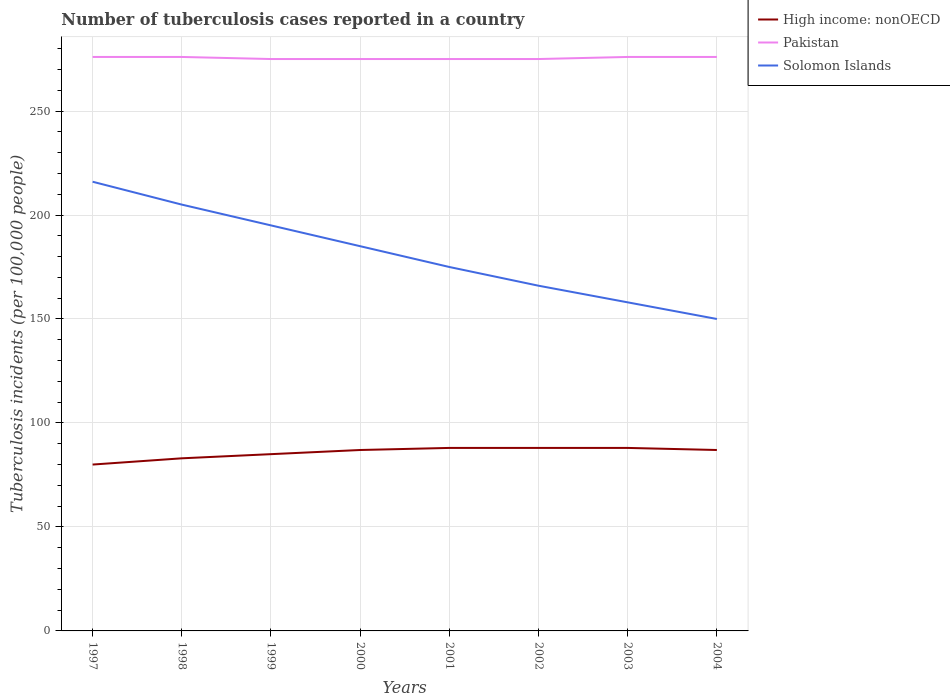Is the number of lines equal to the number of legend labels?
Your answer should be compact. Yes. Across all years, what is the maximum number of tuberculosis cases reported in in Solomon Islands?
Make the answer very short. 150. In which year was the number of tuberculosis cases reported in in Pakistan maximum?
Ensure brevity in your answer.  1999. What is the difference between the highest and the second highest number of tuberculosis cases reported in in High income: nonOECD?
Offer a very short reply. 8. How many lines are there?
Give a very brief answer. 3. Does the graph contain any zero values?
Provide a succinct answer. No. Where does the legend appear in the graph?
Offer a terse response. Top right. How many legend labels are there?
Provide a short and direct response. 3. What is the title of the graph?
Make the answer very short. Number of tuberculosis cases reported in a country. Does "High income: nonOECD" appear as one of the legend labels in the graph?
Your answer should be very brief. Yes. What is the label or title of the X-axis?
Your answer should be compact. Years. What is the label or title of the Y-axis?
Offer a very short reply. Tuberculosis incidents (per 100,0 people). What is the Tuberculosis incidents (per 100,000 people) of Pakistan in 1997?
Offer a very short reply. 276. What is the Tuberculosis incidents (per 100,000 people) of Solomon Islands in 1997?
Offer a very short reply. 216. What is the Tuberculosis incidents (per 100,000 people) in Pakistan in 1998?
Your answer should be very brief. 276. What is the Tuberculosis incidents (per 100,000 people) in Solomon Islands in 1998?
Provide a short and direct response. 205. What is the Tuberculosis incidents (per 100,000 people) in Pakistan in 1999?
Provide a succinct answer. 275. What is the Tuberculosis incidents (per 100,000 people) of Solomon Islands in 1999?
Ensure brevity in your answer.  195. What is the Tuberculosis incidents (per 100,000 people) of High income: nonOECD in 2000?
Give a very brief answer. 87. What is the Tuberculosis incidents (per 100,000 people) in Pakistan in 2000?
Make the answer very short. 275. What is the Tuberculosis incidents (per 100,000 people) in Solomon Islands in 2000?
Offer a terse response. 185. What is the Tuberculosis incidents (per 100,000 people) in Pakistan in 2001?
Give a very brief answer. 275. What is the Tuberculosis incidents (per 100,000 people) of Solomon Islands in 2001?
Your answer should be very brief. 175. What is the Tuberculosis incidents (per 100,000 people) of Pakistan in 2002?
Give a very brief answer. 275. What is the Tuberculosis incidents (per 100,000 people) in Solomon Islands in 2002?
Make the answer very short. 166. What is the Tuberculosis incidents (per 100,000 people) of High income: nonOECD in 2003?
Offer a very short reply. 88. What is the Tuberculosis incidents (per 100,000 people) in Pakistan in 2003?
Provide a short and direct response. 276. What is the Tuberculosis incidents (per 100,000 people) in Solomon Islands in 2003?
Your answer should be very brief. 158. What is the Tuberculosis incidents (per 100,000 people) of High income: nonOECD in 2004?
Offer a terse response. 87. What is the Tuberculosis incidents (per 100,000 people) in Pakistan in 2004?
Offer a terse response. 276. What is the Tuberculosis incidents (per 100,000 people) in Solomon Islands in 2004?
Keep it short and to the point. 150. Across all years, what is the maximum Tuberculosis incidents (per 100,000 people) of Pakistan?
Your answer should be compact. 276. Across all years, what is the maximum Tuberculosis incidents (per 100,000 people) of Solomon Islands?
Your answer should be compact. 216. Across all years, what is the minimum Tuberculosis incidents (per 100,000 people) in Pakistan?
Your answer should be compact. 275. Across all years, what is the minimum Tuberculosis incidents (per 100,000 people) in Solomon Islands?
Give a very brief answer. 150. What is the total Tuberculosis incidents (per 100,000 people) in High income: nonOECD in the graph?
Provide a succinct answer. 686. What is the total Tuberculosis incidents (per 100,000 people) in Pakistan in the graph?
Provide a succinct answer. 2204. What is the total Tuberculosis incidents (per 100,000 people) of Solomon Islands in the graph?
Keep it short and to the point. 1450. What is the difference between the Tuberculosis incidents (per 100,000 people) in High income: nonOECD in 1997 and that in 1998?
Ensure brevity in your answer.  -3. What is the difference between the Tuberculosis incidents (per 100,000 people) of Pakistan in 1997 and that in 1998?
Provide a succinct answer. 0. What is the difference between the Tuberculosis incidents (per 100,000 people) of Solomon Islands in 1997 and that in 1998?
Your response must be concise. 11. What is the difference between the Tuberculosis incidents (per 100,000 people) in Pakistan in 1997 and that in 1999?
Make the answer very short. 1. What is the difference between the Tuberculosis incidents (per 100,000 people) in High income: nonOECD in 1997 and that in 2000?
Provide a short and direct response. -7. What is the difference between the Tuberculosis incidents (per 100,000 people) of Pakistan in 1997 and that in 2000?
Provide a short and direct response. 1. What is the difference between the Tuberculosis incidents (per 100,000 people) in Pakistan in 1997 and that in 2002?
Offer a terse response. 1. What is the difference between the Tuberculosis incidents (per 100,000 people) in Solomon Islands in 1997 and that in 2004?
Ensure brevity in your answer.  66. What is the difference between the Tuberculosis incidents (per 100,000 people) of Pakistan in 1998 and that in 1999?
Your answer should be very brief. 1. What is the difference between the Tuberculosis incidents (per 100,000 people) of Solomon Islands in 1998 and that in 1999?
Your answer should be very brief. 10. What is the difference between the Tuberculosis incidents (per 100,000 people) in Pakistan in 1998 and that in 2000?
Provide a succinct answer. 1. What is the difference between the Tuberculosis incidents (per 100,000 people) in High income: nonOECD in 1998 and that in 2001?
Make the answer very short. -5. What is the difference between the Tuberculosis incidents (per 100,000 people) of Pakistan in 1998 and that in 2001?
Offer a very short reply. 1. What is the difference between the Tuberculosis incidents (per 100,000 people) in Solomon Islands in 1998 and that in 2001?
Your answer should be very brief. 30. What is the difference between the Tuberculosis incidents (per 100,000 people) of High income: nonOECD in 1998 and that in 2002?
Your response must be concise. -5. What is the difference between the Tuberculosis incidents (per 100,000 people) in Solomon Islands in 1998 and that in 2002?
Ensure brevity in your answer.  39. What is the difference between the Tuberculosis incidents (per 100,000 people) of High income: nonOECD in 1998 and that in 2003?
Your response must be concise. -5. What is the difference between the Tuberculosis incidents (per 100,000 people) of Pakistan in 1998 and that in 2004?
Give a very brief answer. 0. What is the difference between the Tuberculosis incidents (per 100,000 people) of Solomon Islands in 1999 and that in 2000?
Provide a short and direct response. 10. What is the difference between the Tuberculosis incidents (per 100,000 people) in High income: nonOECD in 1999 and that in 2001?
Provide a succinct answer. -3. What is the difference between the Tuberculosis incidents (per 100,000 people) of Solomon Islands in 1999 and that in 2002?
Offer a very short reply. 29. What is the difference between the Tuberculosis incidents (per 100,000 people) in High income: nonOECD in 1999 and that in 2003?
Your response must be concise. -3. What is the difference between the Tuberculosis incidents (per 100,000 people) in Pakistan in 1999 and that in 2003?
Your answer should be very brief. -1. What is the difference between the Tuberculosis incidents (per 100,000 people) in Solomon Islands in 1999 and that in 2003?
Give a very brief answer. 37. What is the difference between the Tuberculosis incidents (per 100,000 people) of High income: nonOECD in 1999 and that in 2004?
Give a very brief answer. -2. What is the difference between the Tuberculosis incidents (per 100,000 people) of High income: nonOECD in 2000 and that in 2002?
Keep it short and to the point. -1. What is the difference between the Tuberculosis incidents (per 100,000 people) of Pakistan in 2000 and that in 2002?
Give a very brief answer. 0. What is the difference between the Tuberculosis incidents (per 100,000 people) of Solomon Islands in 2000 and that in 2002?
Keep it short and to the point. 19. What is the difference between the Tuberculosis incidents (per 100,000 people) in High income: nonOECD in 2000 and that in 2003?
Offer a very short reply. -1. What is the difference between the Tuberculosis incidents (per 100,000 people) of Pakistan in 2000 and that in 2003?
Provide a succinct answer. -1. What is the difference between the Tuberculosis incidents (per 100,000 people) in High income: nonOECD in 2000 and that in 2004?
Your answer should be compact. 0. What is the difference between the Tuberculosis incidents (per 100,000 people) in Solomon Islands in 2000 and that in 2004?
Your answer should be compact. 35. What is the difference between the Tuberculosis incidents (per 100,000 people) in Solomon Islands in 2001 and that in 2002?
Your answer should be compact. 9. What is the difference between the Tuberculosis incidents (per 100,000 people) of High income: nonOECD in 2001 and that in 2003?
Your response must be concise. 0. What is the difference between the Tuberculosis incidents (per 100,000 people) in Pakistan in 2001 and that in 2003?
Ensure brevity in your answer.  -1. What is the difference between the Tuberculosis incidents (per 100,000 people) in Pakistan in 2001 and that in 2004?
Your answer should be very brief. -1. What is the difference between the Tuberculosis incidents (per 100,000 people) in Solomon Islands in 2001 and that in 2004?
Provide a succinct answer. 25. What is the difference between the Tuberculosis incidents (per 100,000 people) in Solomon Islands in 2002 and that in 2003?
Your answer should be compact. 8. What is the difference between the Tuberculosis incidents (per 100,000 people) in High income: nonOECD in 2002 and that in 2004?
Make the answer very short. 1. What is the difference between the Tuberculosis incidents (per 100,000 people) in Pakistan in 2002 and that in 2004?
Your response must be concise. -1. What is the difference between the Tuberculosis incidents (per 100,000 people) of Solomon Islands in 2002 and that in 2004?
Offer a terse response. 16. What is the difference between the Tuberculosis incidents (per 100,000 people) of Pakistan in 2003 and that in 2004?
Give a very brief answer. 0. What is the difference between the Tuberculosis incidents (per 100,000 people) of High income: nonOECD in 1997 and the Tuberculosis incidents (per 100,000 people) of Pakistan in 1998?
Make the answer very short. -196. What is the difference between the Tuberculosis incidents (per 100,000 people) in High income: nonOECD in 1997 and the Tuberculosis incidents (per 100,000 people) in Solomon Islands in 1998?
Your answer should be very brief. -125. What is the difference between the Tuberculosis incidents (per 100,000 people) of Pakistan in 1997 and the Tuberculosis incidents (per 100,000 people) of Solomon Islands in 1998?
Provide a short and direct response. 71. What is the difference between the Tuberculosis incidents (per 100,000 people) of High income: nonOECD in 1997 and the Tuberculosis incidents (per 100,000 people) of Pakistan in 1999?
Your answer should be compact. -195. What is the difference between the Tuberculosis incidents (per 100,000 people) in High income: nonOECD in 1997 and the Tuberculosis incidents (per 100,000 people) in Solomon Islands in 1999?
Your response must be concise. -115. What is the difference between the Tuberculosis incidents (per 100,000 people) in High income: nonOECD in 1997 and the Tuberculosis incidents (per 100,000 people) in Pakistan in 2000?
Your answer should be compact. -195. What is the difference between the Tuberculosis incidents (per 100,000 people) in High income: nonOECD in 1997 and the Tuberculosis incidents (per 100,000 people) in Solomon Islands in 2000?
Offer a very short reply. -105. What is the difference between the Tuberculosis incidents (per 100,000 people) of Pakistan in 1997 and the Tuberculosis incidents (per 100,000 people) of Solomon Islands in 2000?
Offer a terse response. 91. What is the difference between the Tuberculosis incidents (per 100,000 people) of High income: nonOECD in 1997 and the Tuberculosis incidents (per 100,000 people) of Pakistan in 2001?
Provide a short and direct response. -195. What is the difference between the Tuberculosis incidents (per 100,000 people) of High income: nonOECD in 1997 and the Tuberculosis incidents (per 100,000 people) of Solomon Islands in 2001?
Make the answer very short. -95. What is the difference between the Tuberculosis incidents (per 100,000 people) in Pakistan in 1997 and the Tuberculosis incidents (per 100,000 people) in Solomon Islands in 2001?
Keep it short and to the point. 101. What is the difference between the Tuberculosis incidents (per 100,000 people) in High income: nonOECD in 1997 and the Tuberculosis incidents (per 100,000 people) in Pakistan in 2002?
Offer a terse response. -195. What is the difference between the Tuberculosis incidents (per 100,000 people) in High income: nonOECD in 1997 and the Tuberculosis incidents (per 100,000 people) in Solomon Islands in 2002?
Your answer should be very brief. -86. What is the difference between the Tuberculosis incidents (per 100,000 people) of Pakistan in 1997 and the Tuberculosis incidents (per 100,000 people) of Solomon Islands in 2002?
Give a very brief answer. 110. What is the difference between the Tuberculosis incidents (per 100,000 people) of High income: nonOECD in 1997 and the Tuberculosis incidents (per 100,000 people) of Pakistan in 2003?
Your answer should be compact. -196. What is the difference between the Tuberculosis incidents (per 100,000 people) of High income: nonOECD in 1997 and the Tuberculosis incidents (per 100,000 people) of Solomon Islands in 2003?
Provide a succinct answer. -78. What is the difference between the Tuberculosis incidents (per 100,000 people) in Pakistan in 1997 and the Tuberculosis incidents (per 100,000 people) in Solomon Islands in 2003?
Provide a short and direct response. 118. What is the difference between the Tuberculosis incidents (per 100,000 people) of High income: nonOECD in 1997 and the Tuberculosis incidents (per 100,000 people) of Pakistan in 2004?
Give a very brief answer. -196. What is the difference between the Tuberculosis incidents (per 100,000 people) of High income: nonOECD in 1997 and the Tuberculosis incidents (per 100,000 people) of Solomon Islands in 2004?
Your answer should be very brief. -70. What is the difference between the Tuberculosis incidents (per 100,000 people) of Pakistan in 1997 and the Tuberculosis incidents (per 100,000 people) of Solomon Islands in 2004?
Offer a very short reply. 126. What is the difference between the Tuberculosis incidents (per 100,000 people) of High income: nonOECD in 1998 and the Tuberculosis incidents (per 100,000 people) of Pakistan in 1999?
Keep it short and to the point. -192. What is the difference between the Tuberculosis incidents (per 100,000 people) of High income: nonOECD in 1998 and the Tuberculosis incidents (per 100,000 people) of Solomon Islands in 1999?
Offer a terse response. -112. What is the difference between the Tuberculosis incidents (per 100,000 people) in Pakistan in 1998 and the Tuberculosis incidents (per 100,000 people) in Solomon Islands in 1999?
Offer a very short reply. 81. What is the difference between the Tuberculosis incidents (per 100,000 people) in High income: nonOECD in 1998 and the Tuberculosis incidents (per 100,000 people) in Pakistan in 2000?
Your answer should be compact. -192. What is the difference between the Tuberculosis incidents (per 100,000 people) of High income: nonOECD in 1998 and the Tuberculosis incidents (per 100,000 people) of Solomon Islands in 2000?
Your response must be concise. -102. What is the difference between the Tuberculosis incidents (per 100,000 people) in Pakistan in 1998 and the Tuberculosis incidents (per 100,000 people) in Solomon Islands in 2000?
Your response must be concise. 91. What is the difference between the Tuberculosis incidents (per 100,000 people) of High income: nonOECD in 1998 and the Tuberculosis incidents (per 100,000 people) of Pakistan in 2001?
Your answer should be compact. -192. What is the difference between the Tuberculosis incidents (per 100,000 people) of High income: nonOECD in 1998 and the Tuberculosis incidents (per 100,000 people) of Solomon Islands in 2001?
Give a very brief answer. -92. What is the difference between the Tuberculosis incidents (per 100,000 people) of Pakistan in 1998 and the Tuberculosis incidents (per 100,000 people) of Solomon Islands in 2001?
Make the answer very short. 101. What is the difference between the Tuberculosis incidents (per 100,000 people) of High income: nonOECD in 1998 and the Tuberculosis incidents (per 100,000 people) of Pakistan in 2002?
Your answer should be compact. -192. What is the difference between the Tuberculosis incidents (per 100,000 people) in High income: nonOECD in 1998 and the Tuberculosis incidents (per 100,000 people) in Solomon Islands in 2002?
Provide a succinct answer. -83. What is the difference between the Tuberculosis incidents (per 100,000 people) of Pakistan in 1998 and the Tuberculosis incidents (per 100,000 people) of Solomon Islands in 2002?
Your answer should be very brief. 110. What is the difference between the Tuberculosis incidents (per 100,000 people) in High income: nonOECD in 1998 and the Tuberculosis incidents (per 100,000 people) in Pakistan in 2003?
Provide a short and direct response. -193. What is the difference between the Tuberculosis incidents (per 100,000 people) of High income: nonOECD in 1998 and the Tuberculosis incidents (per 100,000 people) of Solomon Islands in 2003?
Keep it short and to the point. -75. What is the difference between the Tuberculosis incidents (per 100,000 people) of Pakistan in 1998 and the Tuberculosis incidents (per 100,000 people) of Solomon Islands in 2003?
Ensure brevity in your answer.  118. What is the difference between the Tuberculosis incidents (per 100,000 people) in High income: nonOECD in 1998 and the Tuberculosis incidents (per 100,000 people) in Pakistan in 2004?
Ensure brevity in your answer.  -193. What is the difference between the Tuberculosis incidents (per 100,000 people) in High income: nonOECD in 1998 and the Tuberculosis incidents (per 100,000 people) in Solomon Islands in 2004?
Keep it short and to the point. -67. What is the difference between the Tuberculosis incidents (per 100,000 people) of Pakistan in 1998 and the Tuberculosis incidents (per 100,000 people) of Solomon Islands in 2004?
Ensure brevity in your answer.  126. What is the difference between the Tuberculosis incidents (per 100,000 people) of High income: nonOECD in 1999 and the Tuberculosis incidents (per 100,000 people) of Pakistan in 2000?
Offer a very short reply. -190. What is the difference between the Tuberculosis incidents (per 100,000 people) in High income: nonOECD in 1999 and the Tuberculosis incidents (per 100,000 people) in Solomon Islands in 2000?
Your answer should be very brief. -100. What is the difference between the Tuberculosis incidents (per 100,000 people) of High income: nonOECD in 1999 and the Tuberculosis incidents (per 100,000 people) of Pakistan in 2001?
Give a very brief answer. -190. What is the difference between the Tuberculosis incidents (per 100,000 people) of High income: nonOECD in 1999 and the Tuberculosis incidents (per 100,000 people) of Solomon Islands in 2001?
Make the answer very short. -90. What is the difference between the Tuberculosis incidents (per 100,000 people) in Pakistan in 1999 and the Tuberculosis incidents (per 100,000 people) in Solomon Islands in 2001?
Make the answer very short. 100. What is the difference between the Tuberculosis incidents (per 100,000 people) in High income: nonOECD in 1999 and the Tuberculosis incidents (per 100,000 people) in Pakistan in 2002?
Your answer should be compact. -190. What is the difference between the Tuberculosis incidents (per 100,000 people) in High income: nonOECD in 1999 and the Tuberculosis incidents (per 100,000 people) in Solomon Islands in 2002?
Offer a very short reply. -81. What is the difference between the Tuberculosis incidents (per 100,000 people) in Pakistan in 1999 and the Tuberculosis incidents (per 100,000 people) in Solomon Islands in 2002?
Offer a terse response. 109. What is the difference between the Tuberculosis incidents (per 100,000 people) of High income: nonOECD in 1999 and the Tuberculosis incidents (per 100,000 people) of Pakistan in 2003?
Make the answer very short. -191. What is the difference between the Tuberculosis incidents (per 100,000 people) of High income: nonOECD in 1999 and the Tuberculosis incidents (per 100,000 people) of Solomon Islands in 2003?
Provide a succinct answer. -73. What is the difference between the Tuberculosis incidents (per 100,000 people) in Pakistan in 1999 and the Tuberculosis incidents (per 100,000 people) in Solomon Islands in 2003?
Offer a very short reply. 117. What is the difference between the Tuberculosis incidents (per 100,000 people) of High income: nonOECD in 1999 and the Tuberculosis incidents (per 100,000 people) of Pakistan in 2004?
Provide a succinct answer. -191. What is the difference between the Tuberculosis incidents (per 100,000 people) of High income: nonOECD in 1999 and the Tuberculosis incidents (per 100,000 people) of Solomon Islands in 2004?
Keep it short and to the point. -65. What is the difference between the Tuberculosis incidents (per 100,000 people) of Pakistan in 1999 and the Tuberculosis incidents (per 100,000 people) of Solomon Islands in 2004?
Ensure brevity in your answer.  125. What is the difference between the Tuberculosis incidents (per 100,000 people) in High income: nonOECD in 2000 and the Tuberculosis incidents (per 100,000 people) in Pakistan in 2001?
Offer a very short reply. -188. What is the difference between the Tuberculosis incidents (per 100,000 people) of High income: nonOECD in 2000 and the Tuberculosis incidents (per 100,000 people) of Solomon Islands in 2001?
Keep it short and to the point. -88. What is the difference between the Tuberculosis incidents (per 100,000 people) of Pakistan in 2000 and the Tuberculosis incidents (per 100,000 people) of Solomon Islands in 2001?
Offer a terse response. 100. What is the difference between the Tuberculosis incidents (per 100,000 people) of High income: nonOECD in 2000 and the Tuberculosis incidents (per 100,000 people) of Pakistan in 2002?
Your answer should be compact. -188. What is the difference between the Tuberculosis incidents (per 100,000 people) in High income: nonOECD in 2000 and the Tuberculosis incidents (per 100,000 people) in Solomon Islands in 2002?
Your response must be concise. -79. What is the difference between the Tuberculosis incidents (per 100,000 people) of Pakistan in 2000 and the Tuberculosis incidents (per 100,000 people) of Solomon Islands in 2002?
Provide a short and direct response. 109. What is the difference between the Tuberculosis incidents (per 100,000 people) of High income: nonOECD in 2000 and the Tuberculosis incidents (per 100,000 people) of Pakistan in 2003?
Keep it short and to the point. -189. What is the difference between the Tuberculosis incidents (per 100,000 people) in High income: nonOECD in 2000 and the Tuberculosis incidents (per 100,000 people) in Solomon Islands in 2003?
Make the answer very short. -71. What is the difference between the Tuberculosis incidents (per 100,000 people) in Pakistan in 2000 and the Tuberculosis incidents (per 100,000 people) in Solomon Islands in 2003?
Your answer should be compact. 117. What is the difference between the Tuberculosis incidents (per 100,000 people) of High income: nonOECD in 2000 and the Tuberculosis incidents (per 100,000 people) of Pakistan in 2004?
Offer a terse response. -189. What is the difference between the Tuberculosis incidents (per 100,000 people) of High income: nonOECD in 2000 and the Tuberculosis incidents (per 100,000 people) of Solomon Islands in 2004?
Ensure brevity in your answer.  -63. What is the difference between the Tuberculosis incidents (per 100,000 people) in Pakistan in 2000 and the Tuberculosis incidents (per 100,000 people) in Solomon Islands in 2004?
Your answer should be compact. 125. What is the difference between the Tuberculosis incidents (per 100,000 people) in High income: nonOECD in 2001 and the Tuberculosis incidents (per 100,000 people) in Pakistan in 2002?
Offer a terse response. -187. What is the difference between the Tuberculosis incidents (per 100,000 people) in High income: nonOECD in 2001 and the Tuberculosis incidents (per 100,000 people) in Solomon Islands in 2002?
Offer a very short reply. -78. What is the difference between the Tuberculosis incidents (per 100,000 people) in Pakistan in 2001 and the Tuberculosis incidents (per 100,000 people) in Solomon Islands in 2002?
Make the answer very short. 109. What is the difference between the Tuberculosis incidents (per 100,000 people) of High income: nonOECD in 2001 and the Tuberculosis incidents (per 100,000 people) of Pakistan in 2003?
Provide a succinct answer. -188. What is the difference between the Tuberculosis incidents (per 100,000 people) in High income: nonOECD in 2001 and the Tuberculosis incidents (per 100,000 people) in Solomon Islands in 2003?
Provide a short and direct response. -70. What is the difference between the Tuberculosis incidents (per 100,000 people) of Pakistan in 2001 and the Tuberculosis incidents (per 100,000 people) of Solomon Islands in 2003?
Make the answer very short. 117. What is the difference between the Tuberculosis incidents (per 100,000 people) of High income: nonOECD in 2001 and the Tuberculosis incidents (per 100,000 people) of Pakistan in 2004?
Your response must be concise. -188. What is the difference between the Tuberculosis incidents (per 100,000 people) of High income: nonOECD in 2001 and the Tuberculosis incidents (per 100,000 people) of Solomon Islands in 2004?
Offer a terse response. -62. What is the difference between the Tuberculosis incidents (per 100,000 people) of Pakistan in 2001 and the Tuberculosis incidents (per 100,000 people) of Solomon Islands in 2004?
Provide a short and direct response. 125. What is the difference between the Tuberculosis incidents (per 100,000 people) in High income: nonOECD in 2002 and the Tuberculosis incidents (per 100,000 people) in Pakistan in 2003?
Give a very brief answer. -188. What is the difference between the Tuberculosis incidents (per 100,000 people) in High income: nonOECD in 2002 and the Tuberculosis incidents (per 100,000 people) in Solomon Islands in 2003?
Your answer should be compact. -70. What is the difference between the Tuberculosis incidents (per 100,000 people) in Pakistan in 2002 and the Tuberculosis incidents (per 100,000 people) in Solomon Islands in 2003?
Your answer should be very brief. 117. What is the difference between the Tuberculosis incidents (per 100,000 people) in High income: nonOECD in 2002 and the Tuberculosis incidents (per 100,000 people) in Pakistan in 2004?
Provide a succinct answer. -188. What is the difference between the Tuberculosis incidents (per 100,000 people) in High income: nonOECD in 2002 and the Tuberculosis incidents (per 100,000 people) in Solomon Islands in 2004?
Provide a short and direct response. -62. What is the difference between the Tuberculosis incidents (per 100,000 people) of Pakistan in 2002 and the Tuberculosis incidents (per 100,000 people) of Solomon Islands in 2004?
Your response must be concise. 125. What is the difference between the Tuberculosis incidents (per 100,000 people) of High income: nonOECD in 2003 and the Tuberculosis incidents (per 100,000 people) of Pakistan in 2004?
Provide a succinct answer. -188. What is the difference between the Tuberculosis incidents (per 100,000 people) in High income: nonOECD in 2003 and the Tuberculosis incidents (per 100,000 people) in Solomon Islands in 2004?
Your answer should be compact. -62. What is the difference between the Tuberculosis incidents (per 100,000 people) of Pakistan in 2003 and the Tuberculosis incidents (per 100,000 people) of Solomon Islands in 2004?
Your answer should be compact. 126. What is the average Tuberculosis incidents (per 100,000 people) of High income: nonOECD per year?
Your answer should be compact. 85.75. What is the average Tuberculosis incidents (per 100,000 people) of Pakistan per year?
Give a very brief answer. 275.5. What is the average Tuberculosis incidents (per 100,000 people) in Solomon Islands per year?
Your answer should be compact. 181.25. In the year 1997, what is the difference between the Tuberculosis incidents (per 100,000 people) in High income: nonOECD and Tuberculosis incidents (per 100,000 people) in Pakistan?
Your answer should be very brief. -196. In the year 1997, what is the difference between the Tuberculosis incidents (per 100,000 people) in High income: nonOECD and Tuberculosis incidents (per 100,000 people) in Solomon Islands?
Make the answer very short. -136. In the year 1997, what is the difference between the Tuberculosis incidents (per 100,000 people) in Pakistan and Tuberculosis incidents (per 100,000 people) in Solomon Islands?
Offer a very short reply. 60. In the year 1998, what is the difference between the Tuberculosis incidents (per 100,000 people) of High income: nonOECD and Tuberculosis incidents (per 100,000 people) of Pakistan?
Keep it short and to the point. -193. In the year 1998, what is the difference between the Tuberculosis incidents (per 100,000 people) in High income: nonOECD and Tuberculosis incidents (per 100,000 people) in Solomon Islands?
Provide a short and direct response. -122. In the year 1998, what is the difference between the Tuberculosis incidents (per 100,000 people) in Pakistan and Tuberculosis incidents (per 100,000 people) in Solomon Islands?
Provide a succinct answer. 71. In the year 1999, what is the difference between the Tuberculosis incidents (per 100,000 people) of High income: nonOECD and Tuberculosis incidents (per 100,000 people) of Pakistan?
Provide a succinct answer. -190. In the year 1999, what is the difference between the Tuberculosis incidents (per 100,000 people) in High income: nonOECD and Tuberculosis incidents (per 100,000 people) in Solomon Islands?
Your answer should be very brief. -110. In the year 2000, what is the difference between the Tuberculosis incidents (per 100,000 people) in High income: nonOECD and Tuberculosis incidents (per 100,000 people) in Pakistan?
Give a very brief answer. -188. In the year 2000, what is the difference between the Tuberculosis incidents (per 100,000 people) of High income: nonOECD and Tuberculosis incidents (per 100,000 people) of Solomon Islands?
Make the answer very short. -98. In the year 2000, what is the difference between the Tuberculosis incidents (per 100,000 people) in Pakistan and Tuberculosis incidents (per 100,000 people) in Solomon Islands?
Your response must be concise. 90. In the year 2001, what is the difference between the Tuberculosis incidents (per 100,000 people) in High income: nonOECD and Tuberculosis incidents (per 100,000 people) in Pakistan?
Offer a very short reply. -187. In the year 2001, what is the difference between the Tuberculosis incidents (per 100,000 people) of High income: nonOECD and Tuberculosis incidents (per 100,000 people) of Solomon Islands?
Ensure brevity in your answer.  -87. In the year 2001, what is the difference between the Tuberculosis incidents (per 100,000 people) in Pakistan and Tuberculosis incidents (per 100,000 people) in Solomon Islands?
Give a very brief answer. 100. In the year 2002, what is the difference between the Tuberculosis incidents (per 100,000 people) in High income: nonOECD and Tuberculosis incidents (per 100,000 people) in Pakistan?
Offer a very short reply. -187. In the year 2002, what is the difference between the Tuberculosis incidents (per 100,000 people) of High income: nonOECD and Tuberculosis incidents (per 100,000 people) of Solomon Islands?
Your answer should be compact. -78. In the year 2002, what is the difference between the Tuberculosis incidents (per 100,000 people) in Pakistan and Tuberculosis incidents (per 100,000 people) in Solomon Islands?
Your answer should be very brief. 109. In the year 2003, what is the difference between the Tuberculosis incidents (per 100,000 people) in High income: nonOECD and Tuberculosis incidents (per 100,000 people) in Pakistan?
Provide a succinct answer. -188. In the year 2003, what is the difference between the Tuberculosis incidents (per 100,000 people) of High income: nonOECD and Tuberculosis incidents (per 100,000 people) of Solomon Islands?
Your answer should be compact. -70. In the year 2003, what is the difference between the Tuberculosis incidents (per 100,000 people) of Pakistan and Tuberculosis incidents (per 100,000 people) of Solomon Islands?
Your answer should be very brief. 118. In the year 2004, what is the difference between the Tuberculosis incidents (per 100,000 people) of High income: nonOECD and Tuberculosis incidents (per 100,000 people) of Pakistan?
Provide a short and direct response. -189. In the year 2004, what is the difference between the Tuberculosis incidents (per 100,000 people) of High income: nonOECD and Tuberculosis incidents (per 100,000 people) of Solomon Islands?
Provide a short and direct response. -63. In the year 2004, what is the difference between the Tuberculosis incidents (per 100,000 people) of Pakistan and Tuberculosis incidents (per 100,000 people) of Solomon Islands?
Ensure brevity in your answer.  126. What is the ratio of the Tuberculosis incidents (per 100,000 people) in High income: nonOECD in 1997 to that in 1998?
Your answer should be very brief. 0.96. What is the ratio of the Tuberculosis incidents (per 100,000 people) in Solomon Islands in 1997 to that in 1998?
Give a very brief answer. 1.05. What is the ratio of the Tuberculosis incidents (per 100,000 people) of High income: nonOECD in 1997 to that in 1999?
Provide a short and direct response. 0.94. What is the ratio of the Tuberculosis incidents (per 100,000 people) in Pakistan in 1997 to that in 1999?
Ensure brevity in your answer.  1. What is the ratio of the Tuberculosis incidents (per 100,000 people) in Solomon Islands in 1997 to that in 1999?
Your response must be concise. 1.11. What is the ratio of the Tuberculosis incidents (per 100,000 people) of High income: nonOECD in 1997 to that in 2000?
Keep it short and to the point. 0.92. What is the ratio of the Tuberculosis incidents (per 100,000 people) of Pakistan in 1997 to that in 2000?
Ensure brevity in your answer.  1. What is the ratio of the Tuberculosis incidents (per 100,000 people) of Solomon Islands in 1997 to that in 2000?
Offer a very short reply. 1.17. What is the ratio of the Tuberculosis incidents (per 100,000 people) of High income: nonOECD in 1997 to that in 2001?
Your response must be concise. 0.91. What is the ratio of the Tuberculosis incidents (per 100,000 people) of Pakistan in 1997 to that in 2001?
Give a very brief answer. 1. What is the ratio of the Tuberculosis incidents (per 100,000 people) in Solomon Islands in 1997 to that in 2001?
Give a very brief answer. 1.23. What is the ratio of the Tuberculosis incidents (per 100,000 people) in High income: nonOECD in 1997 to that in 2002?
Offer a terse response. 0.91. What is the ratio of the Tuberculosis incidents (per 100,000 people) of Pakistan in 1997 to that in 2002?
Provide a succinct answer. 1. What is the ratio of the Tuberculosis incidents (per 100,000 people) in Solomon Islands in 1997 to that in 2002?
Provide a short and direct response. 1.3. What is the ratio of the Tuberculosis incidents (per 100,000 people) in Solomon Islands in 1997 to that in 2003?
Make the answer very short. 1.37. What is the ratio of the Tuberculosis incidents (per 100,000 people) in High income: nonOECD in 1997 to that in 2004?
Your answer should be compact. 0.92. What is the ratio of the Tuberculosis incidents (per 100,000 people) in Solomon Islands in 1997 to that in 2004?
Offer a very short reply. 1.44. What is the ratio of the Tuberculosis incidents (per 100,000 people) of High income: nonOECD in 1998 to that in 1999?
Keep it short and to the point. 0.98. What is the ratio of the Tuberculosis incidents (per 100,000 people) of Pakistan in 1998 to that in 1999?
Offer a terse response. 1. What is the ratio of the Tuberculosis incidents (per 100,000 people) in Solomon Islands in 1998 to that in 1999?
Keep it short and to the point. 1.05. What is the ratio of the Tuberculosis incidents (per 100,000 people) in High income: nonOECD in 1998 to that in 2000?
Offer a terse response. 0.95. What is the ratio of the Tuberculosis incidents (per 100,000 people) of Pakistan in 1998 to that in 2000?
Give a very brief answer. 1. What is the ratio of the Tuberculosis incidents (per 100,000 people) in Solomon Islands in 1998 to that in 2000?
Give a very brief answer. 1.11. What is the ratio of the Tuberculosis incidents (per 100,000 people) of High income: nonOECD in 1998 to that in 2001?
Your answer should be very brief. 0.94. What is the ratio of the Tuberculosis incidents (per 100,000 people) of Solomon Islands in 1998 to that in 2001?
Your response must be concise. 1.17. What is the ratio of the Tuberculosis incidents (per 100,000 people) of High income: nonOECD in 1998 to that in 2002?
Your answer should be compact. 0.94. What is the ratio of the Tuberculosis incidents (per 100,000 people) in Solomon Islands in 1998 to that in 2002?
Your answer should be compact. 1.23. What is the ratio of the Tuberculosis incidents (per 100,000 people) of High income: nonOECD in 1998 to that in 2003?
Your answer should be very brief. 0.94. What is the ratio of the Tuberculosis incidents (per 100,000 people) of Solomon Islands in 1998 to that in 2003?
Your answer should be very brief. 1.3. What is the ratio of the Tuberculosis incidents (per 100,000 people) in High income: nonOECD in 1998 to that in 2004?
Ensure brevity in your answer.  0.95. What is the ratio of the Tuberculosis incidents (per 100,000 people) of Solomon Islands in 1998 to that in 2004?
Offer a terse response. 1.37. What is the ratio of the Tuberculosis incidents (per 100,000 people) of High income: nonOECD in 1999 to that in 2000?
Offer a very short reply. 0.98. What is the ratio of the Tuberculosis incidents (per 100,000 people) in Solomon Islands in 1999 to that in 2000?
Your answer should be very brief. 1.05. What is the ratio of the Tuberculosis incidents (per 100,000 people) of High income: nonOECD in 1999 to that in 2001?
Give a very brief answer. 0.97. What is the ratio of the Tuberculosis incidents (per 100,000 people) of Solomon Islands in 1999 to that in 2001?
Your answer should be compact. 1.11. What is the ratio of the Tuberculosis incidents (per 100,000 people) in High income: nonOECD in 1999 to that in 2002?
Your answer should be very brief. 0.97. What is the ratio of the Tuberculosis incidents (per 100,000 people) of Pakistan in 1999 to that in 2002?
Offer a terse response. 1. What is the ratio of the Tuberculosis incidents (per 100,000 people) in Solomon Islands in 1999 to that in 2002?
Your answer should be very brief. 1.17. What is the ratio of the Tuberculosis incidents (per 100,000 people) of High income: nonOECD in 1999 to that in 2003?
Your answer should be very brief. 0.97. What is the ratio of the Tuberculosis incidents (per 100,000 people) in Solomon Islands in 1999 to that in 2003?
Ensure brevity in your answer.  1.23. What is the ratio of the Tuberculosis incidents (per 100,000 people) in High income: nonOECD in 1999 to that in 2004?
Your answer should be compact. 0.98. What is the ratio of the Tuberculosis incidents (per 100,000 people) of Pakistan in 1999 to that in 2004?
Keep it short and to the point. 1. What is the ratio of the Tuberculosis incidents (per 100,000 people) of Solomon Islands in 2000 to that in 2001?
Give a very brief answer. 1.06. What is the ratio of the Tuberculosis incidents (per 100,000 people) in High income: nonOECD in 2000 to that in 2002?
Offer a very short reply. 0.99. What is the ratio of the Tuberculosis incidents (per 100,000 people) of Solomon Islands in 2000 to that in 2002?
Make the answer very short. 1.11. What is the ratio of the Tuberculosis incidents (per 100,000 people) of High income: nonOECD in 2000 to that in 2003?
Give a very brief answer. 0.99. What is the ratio of the Tuberculosis incidents (per 100,000 people) of Pakistan in 2000 to that in 2003?
Offer a very short reply. 1. What is the ratio of the Tuberculosis incidents (per 100,000 people) of Solomon Islands in 2000 to that in 2003?
Your answer should be compact. 1.17. What is the ratio of the Tuberculosis incidents (per 100,000 people) of High income: nonOECD in 2000 to that in 2004?
Your answer should be compact. 1. What is the ratio of the Tuberculosis incidents (per 100,000 people) of Pakistan in 2000 to that in 2004?
Offer a very short reply. 1. What is the ratio of the Tuberculosis incidents (per 100,000 people) in Solomon Islands in 2000 to that in 2004?
Give a very brief answer. 1.23. What is the ratio of the Tuberculosis incidents (per 100,000 people) of High income: nonOECD in 2001 to that in 2002?
Your answer should be compact. 1. What is the ratio of the Tuberculosis incidents (per 100,000 people) in Solomon Islands in 2001 to that in 2002?
Your answer should be compact. 1.05. What is the ratio of the Tuberculosis incidents (per 100,000 people) of Solomon Islands in 2001 to that in 2003?
Provide a succinct answer. 1.11. What is the ratio of the Tuberculosis incidents (per 100,000 people) of High income: nonOECD in 2001 to that in 2004?
Offer a very short reply. 1.01. What is the ratio of the Tuberculosis incidents (per 100,000 people) in Pakistan in 2002 to that in 2003?
Your answer should be very brief. 1. What is the ratio of the Tuberculosis incidents (per 100,000 people) in Solomon Islands in 2002 to that in 2003?
Your answer should be very brief. 1.05. What is the ratio of the Tuberculosis incidents (per 100,000 people) of High income: nonOECD in 2002 to that in 2004?
Provide a short and direct response. 1.01. What is the ratio of the Tuberculosis incidents (per 100,000 people) in Pakistan in 2002 to that in 2004?
Give a very brief answer. 1. What is the ratio of the Tuberculosis incidents (per 100,000 people) of Solomon Islands in 2002 to that in 2004?
Make the answer very short. 1.11. What is the ratio of the Tuberculosis incidents (per 100,000 people) in High income: nonOECD in 2003 to that in 2004?
Offer a very short reply. 1.01. What is the ratio of the Tuberculosis incidents (per 100,000 people) of Pakistan in 2003 to that in 2004?
Provide a short and direct response. 1. What is the ratio of the Tuberculosis incidents (per 100,000 people) of Solomon Islands in 2003 to that in 2004?
Make the answer very short. 1.05. What is the difference between the highest and the second highest Tuberculosis incidents (per 100,000 people) of High income: nonOECD?
Make the answer very short. 0. What is the difference between the highest and the second highest Tuberculosis incidents (per 100,000 people) of Solomon Islands?
Give a very brief answer. 11. What is the difference between the highest and the lowest Tuberculosis incidents (per 100,000 people) of High income: nonOECD?
Offer a terse response. 8. What is the difference between the highest and the lowest Tuberculosis incidents (per 100,000 people) of Pakistan?
Your response must be concise. 1. 